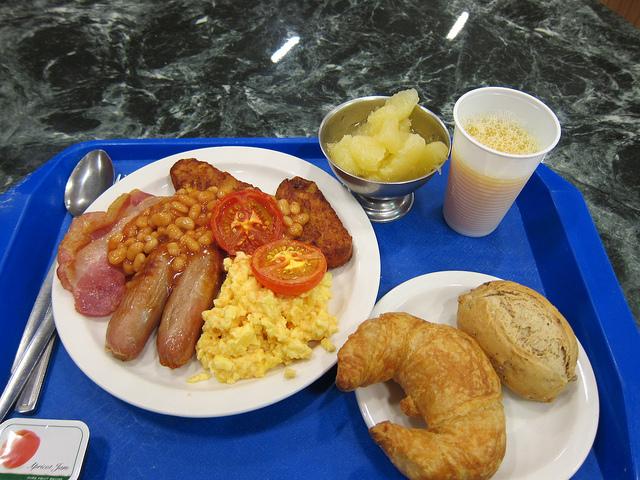What is in the little silver bowl?
Answer briefly. Pineapple. What color is the tray?
Quick response, please. Blue. Is this breakfast?
Answer briefly. Yes. 